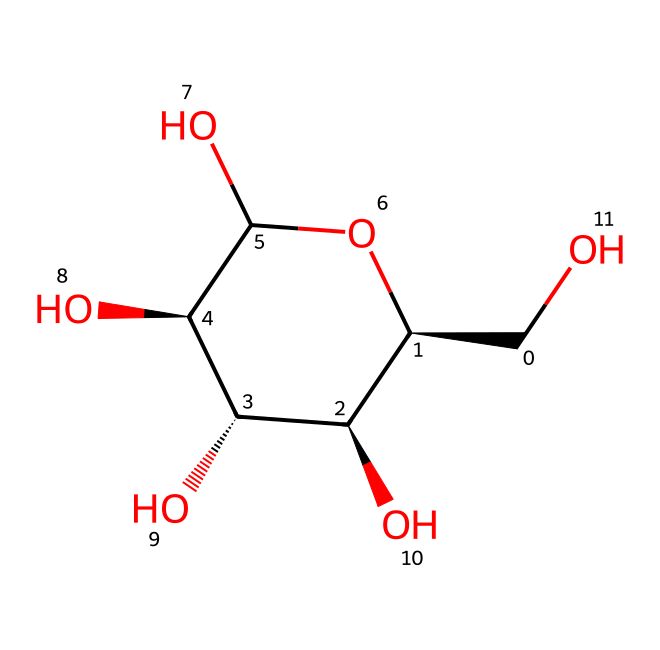what is the molecular formula of this compound? To find the molecular formula, count the number of each type of atom present in the SMILES representation. From the structure, we identify 6 carbon atoms and 12 hydrogen atoms, along with 6 oxygen atoms, leading to the formula C6H12O6.
Answer: C6H12O6 how many hydroxyl (OH) groups are present? By analyzing the structure, we look for -OH functional groups. In this case, there are four hydroxyl groups represented by the various regions in the chemical structure that show bonds to oxygen and hydrogen.
Answer: four what type of compound is this based on its structure? The presence of multiple hydroxyl groups implies that the compound is likely a type of sugar, specifically an aldohexose based on the number of carbons and functional groups.
Answer: sugar how many chiral centers does this molecule have? To determine chiral centers, we look for carbon atoms that are attached to four distinct substituents. In this structure, there are four such carbon atoms, indicating the presence of four chiral centers.
Answer: four is this compound aromatic? Aromatic compounds typically have a conjugated pi electron system with a planar ring structure, following Huckel's rule (4n + 2 pi electrons). This structure lacks the necessary aromatic features (like a cyclic structure with a conjugated system), therefore it is not aromatic.
Answer: no what type of reaction can this compound undergo due to its functional groups? Due to the presence of multiple hydroxyl (OH) groups, this compound can undergo dehydration reactions, resulting in the formation of esters or ethers if reacted with appropriate agents.
Answer: dehydration reactions 